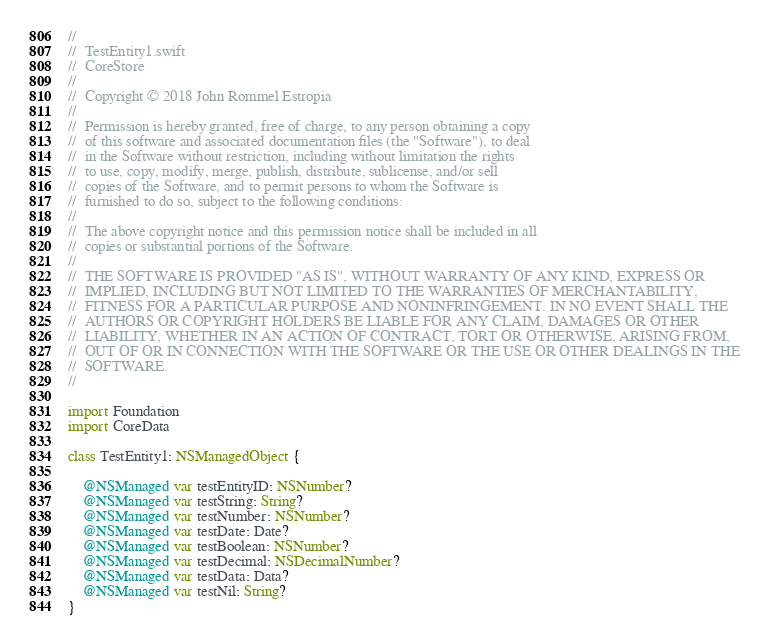<code> <loc_0><loc_0><loc_500><loc_500><_Swift_>//
//  TestEntity1.swift
//  CoreStore
//
//  Copyright © 2018 John Rommel Estropia
//
//  Permission is hereby granted, free of charge, to any person obtaining a copy
//  of this software and associated documentation files (the "Software"), to deal
//  in the Software without restriction, including without limitation the rights
//  to use, copy, modify, merge, publish, distribute, sublicense, and/or sell
//  copies of the Software, and to permit persons to whom the Software is
//  furnished to do so, subject to the following conditions:
//
//  The above copyright notice and this permission notice shall be included in all
//  copies or substantial portions of the Software.
//
//  THE SOFTWARE IS PROVIDED "AS IS", WITHOUT WARRANTY OF ANY KIND, EXPRESS OR
//  IMPLIED, INCLUDING BUT NOT LIMITED TO THE WARRANTIES OF MERCHANTABILITY,
//  FITNESS FOR A PARTICULAR PURPOSE AND NONINFRINGEMENT. IN NO EVENT SHALL THE
//  AUTHORS OR COPYRIGHT HOLDERS BE LIABLE FOR ANY CLAIM, DAMAGES OR OTHER
//  LIABILITY, WHETHER IN AN ACTION OF CONTRACT, TORT OR OTHERWISE, ARISING FROM,
//  OUT OF OR IN CONNECTION WITH THE SOFTWARE OR THE USE OR OTHER DEALINGS IN THE
//  SOFTWARE.
//

import Foundation
import CoreData

class TestEntity1: NSManagedObject {

    @NSManaged var testEntityID: NSNumber?
    @NSManaged var testString: String?
    @NSManaged var testNumber: NSNumber?
    @NSManaged var testDate: Date?
    @NSManaged var testBoolean: NSNumber?
    @NSManaged var testDecimal: NSDecimalNumber?
    @NSManaged var testData: Data?
    @NSManaged var testNil: String?
}
</code> 